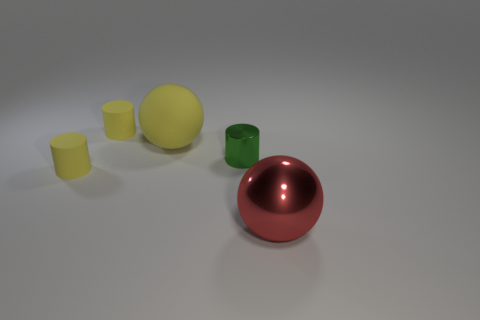Is there a green object that has the same material as the tiny green cylinder?
Give a very brief answer. No. Is the green object made of the same material as the large red sphere?
Your answer should be compact. Yes. What number of tiny matte objects are in front of the large ball that is on the left side of the large red shiny object?
Provide a short and direct response. 1. How many cyan objects are either cylinders or matte things?
Give a very brief answer. 0. What shape is the object in front of the yellow cylinder in front of the big object left of the large red thing?
Offer a very short reply. Sphere. What is the color of the other sphere that is the same size as the yellow matte sphere?
Offer a very short reply. Red. What number of other yellow matte things are the same shape as the big yellow thing?
Give a very brief answer. 0. Is the size of the green thing the same as the red ball in front of the big yellow thing?
Your answer should be compact. No. What is the shape of the yellow thing left of the tiny yellow cylinder that is behind the tiny shiny object?
Give a very brief answer. Cylinder. Is the number of yellow rubber spheres to the left of the green shiny cylinder less than the number of small rubber cubes?
Provide a succinct answer. No. 